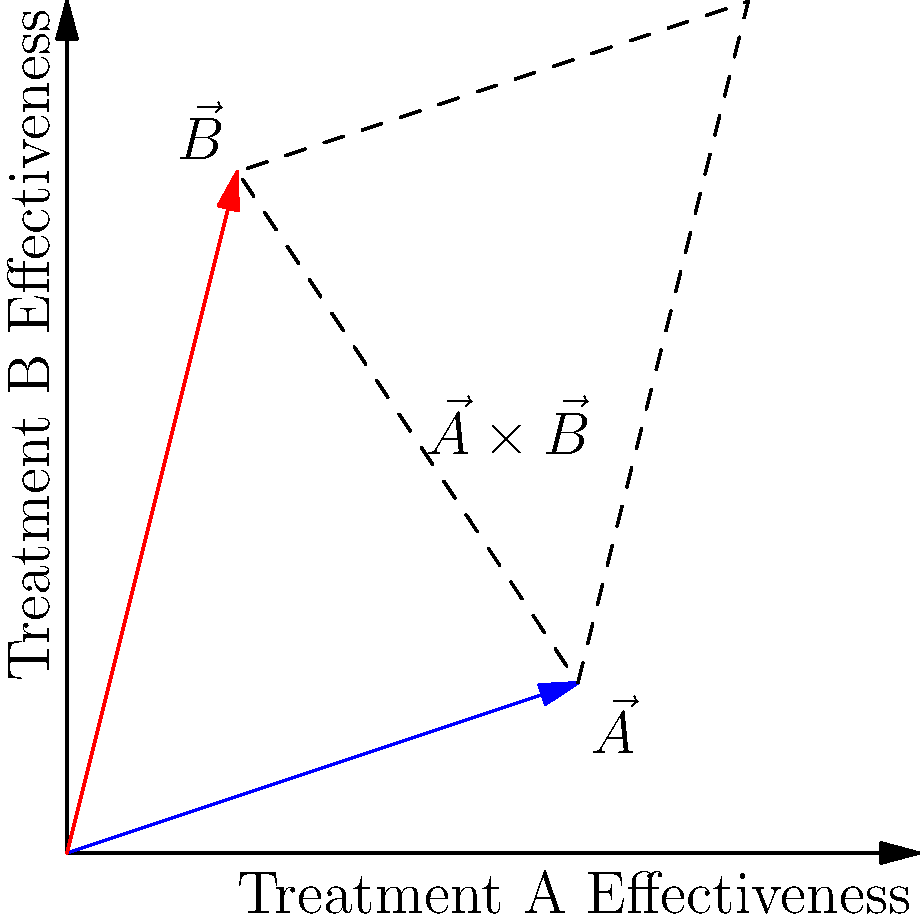In a clinical study, two treatment options A and B are represented by vectors $\vec{A} = (3,1)$ and $\vec{B} = (1,4)$, where the components indicate effectiveness on different aspects of patient recovery. Calculate the magnitude of the cross product $\vec{A} \times \vec{B}$. What does this value represent in the context of the treatments' combined effect? To solve this problem, we'll follow these steps:

1) The cross product of two vectors $\vec{A} = (a_1, a_2)$ and $\vec{B} = (b_1, b_2)$ in 2D is defined as:

   $\vec{A} \times \vec{B} = a_1b_2 - a_2b_1$

2) In this case, $\vec{A} = (3,1)$ and $\vec{B} = (1,4)$. Let's substitute these values:

   $\vec{A} \times \vec{B} = (3)(4) - (1)(1) = 12 - 1 = 11$

3) The magnitude of the cross product is the absolute value of this result:

   $|\vec{A} \times \vec{B}| = |11| = 11$

4) In the context of vectors, the magnitude of the cross product represents the area of the parallelogram formed by the two vectors.

5) For our health-related scenario, this value (11) represents the combined effect of the two treatments. A larger value indicates a greater overall impact on patient recovery when both treatments are used together.

6) This approach aligns with evidence-based medicine, as it quantifies the combined effect of treatments based on their individual effectiveness measures.
Answer: 11; represents the combined effect magnitude of both treatments 